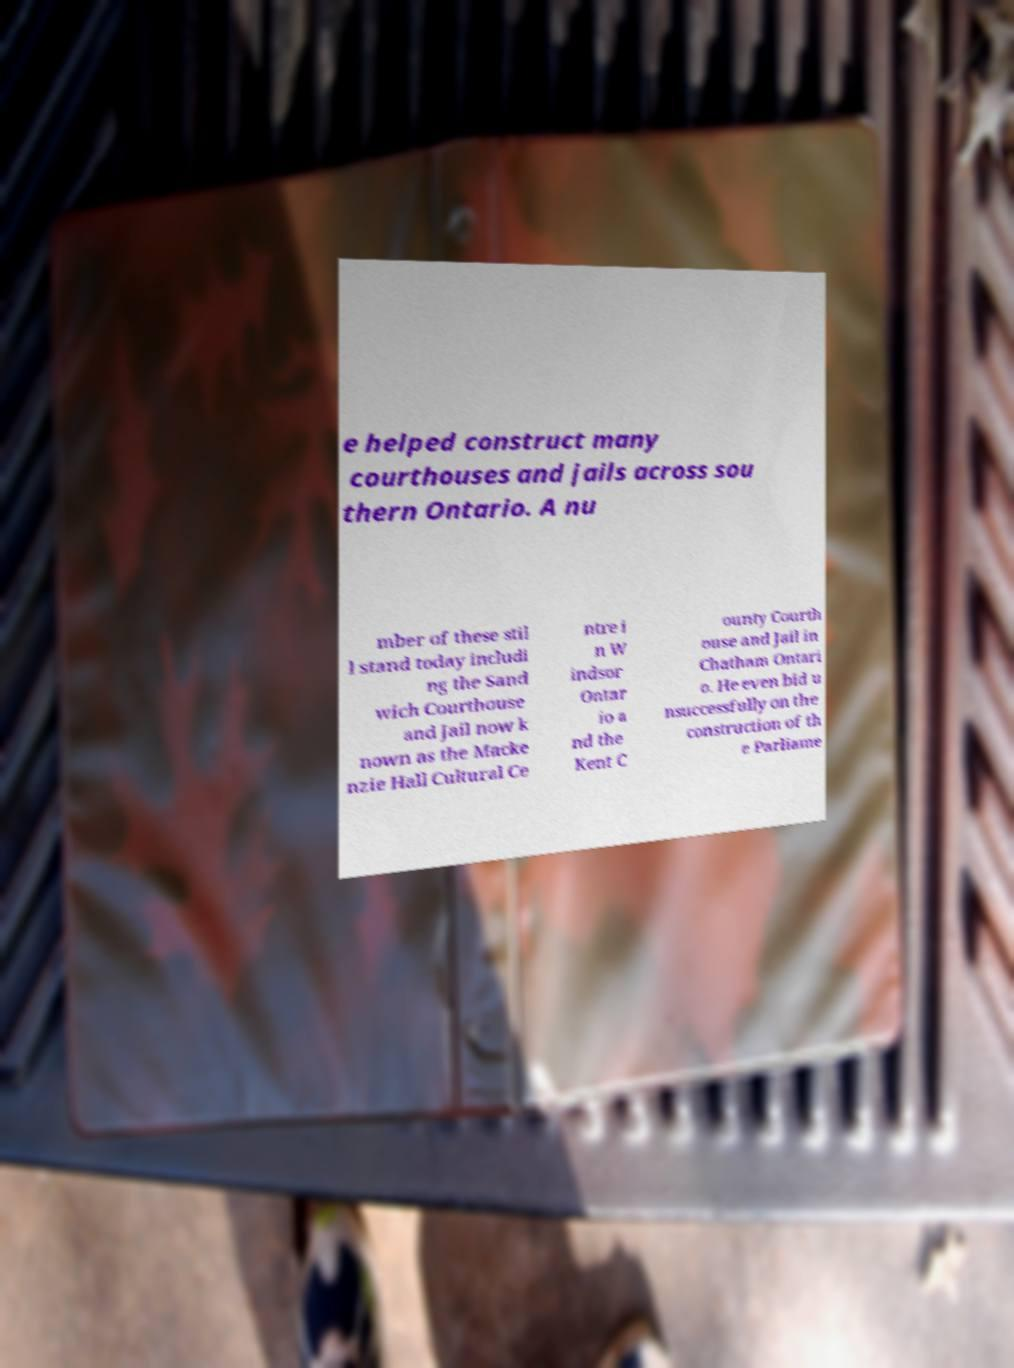Can you read and provide the text displayed in the image?This photo seems to have some interesting text. Can you extract and type it out for me? e helped construct many courthouses and jails across sou thern Ontario. A nu mber of these stil l stand today includi ng the Sand wich Courthouse and Jail now k nown as the Macke nzie Hall Cultural Ce ntre i n W indsor Ontar io a nd the Kent C ounty Courth ouse and Jail in Chatham Ontari o. He even bid u nsuccessfully on the construction of th e Parliame 